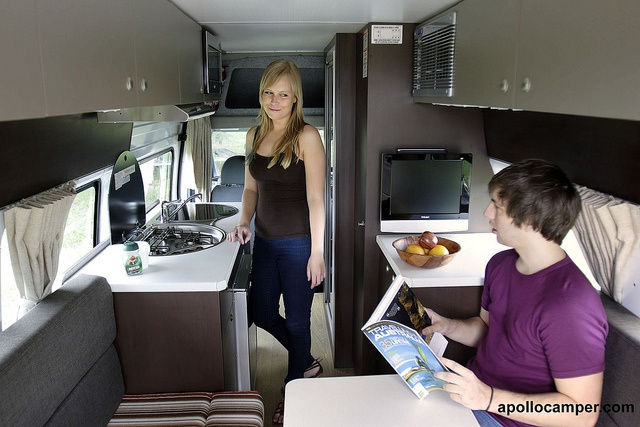Describe the objects in this image and their specific colors. I can see people in gray, purple, black, and lightgray tones, couch in gray, black, and darkgray tones, people in gray, black, and tan tones, dining table in gray, lightgray, and darkgray tones, and tv in gray, black, white, and purple tones in this image. 